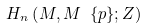Convert formula to latex. <formula><loc_0><loc_0><loc_500><loc_500>H _ { n } \left ( M , M \ \{ p \} ; Z \right )</formula> 